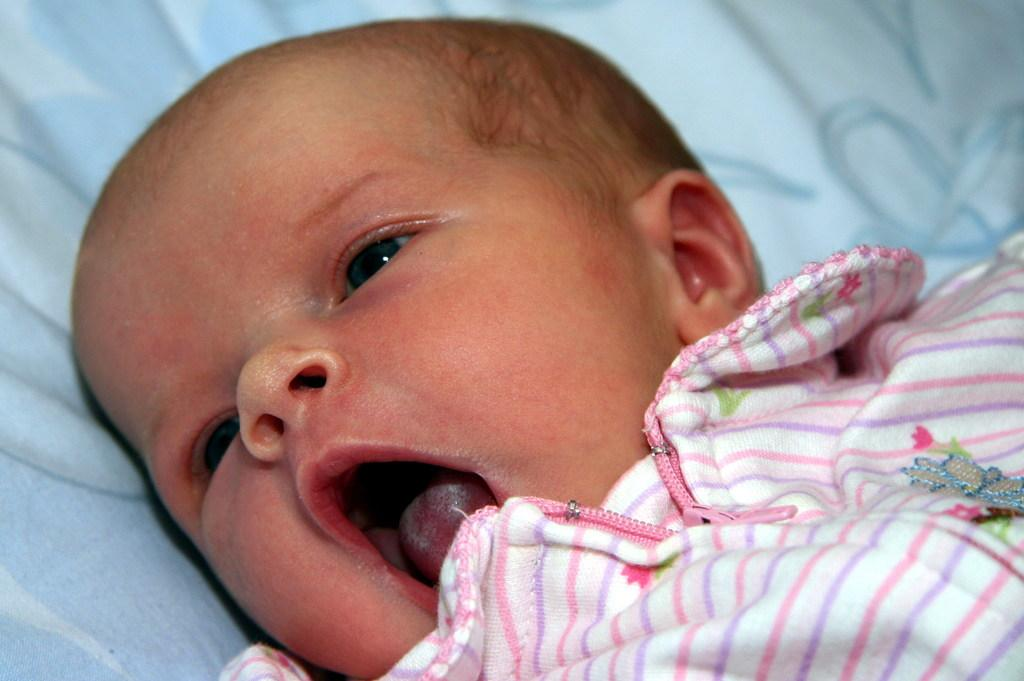What is the main subject of the image? There is a baby in the image. What position is the baby in? The baby is laying down. What is the baby wearing? The baby is wearing a white dress. Can you see any fangs on the baby in the image? There are no fangs visible on the baby in the image. What type of hair does the baby have in the image? The provided facts do not mention the baby's hair, so we cannot determine the type of hair from the image. 